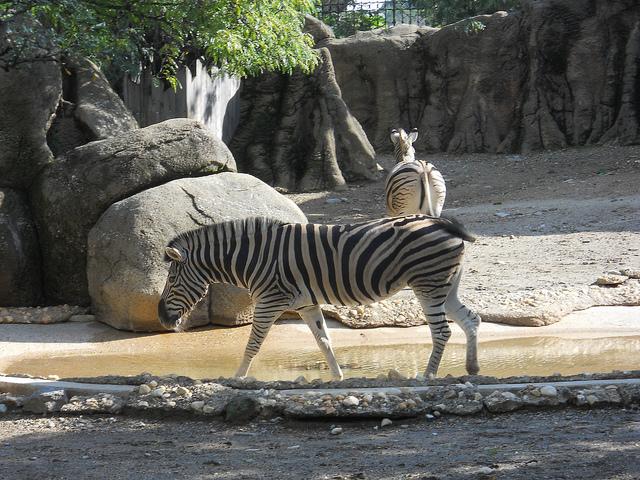Are these animals native to America?
Answer briefly. No. Was this photo taken in the wild?
Give a very brief answer. No. Which direction is the zebra in the foreground facing?
Keep it brief. Left. 